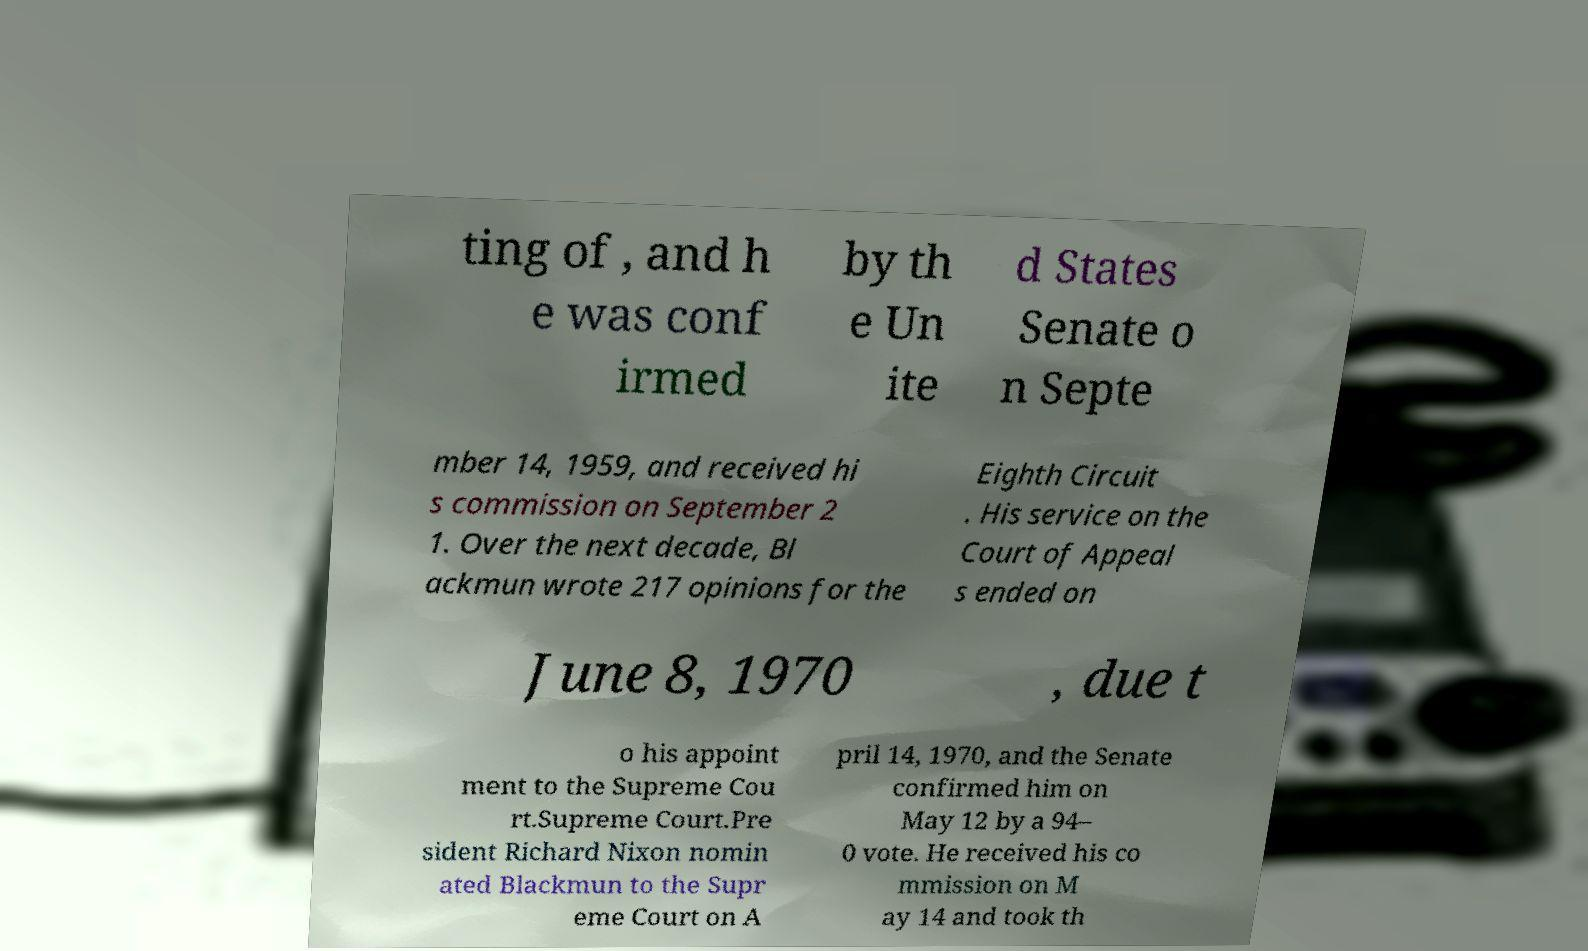What messages or text are displayed in this image? I need them in a readable, typed format. ting of , and h e was conf irmed by th e Un ite d States Senate o n Septe mber 14, 1959, and received hi s commission on September 2 1. Over the next decade, Bl ackmun wrote 217 opinions for the Eighth Circuit . His service on the Court of Appeal s ended on June 8, 1970 , due t o his appoint ment to the Supreme Cou rt.Supreme Court.Pre sident Richard Nixon nomin ated Blackmun to the Supr eme Court on A pril 14, 1970, and the Senate confirmed him on May 12 by a 94– 0 vote. He received his co mmission on M ay 14 and took th 